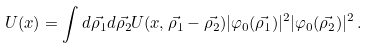Convert formula to latex. <formula><loc_0><loc_0><loc_500><loc_500>U ( x ) = \int d \vec { \rho _ { 1 } } d \vec { \rho _ { 2 } } U ( x , \vec { \rho _ { 1 } } - \vec { \rho _ { 2 } } ) | \varphi _ { 0 } ( \vec { \rho _ { 1 } } ) | ^ { 2 } | \varphi _ { 0 } ( \vec { \rho _ { 2 } } ) | ^ { 2 } \, .</formula> 